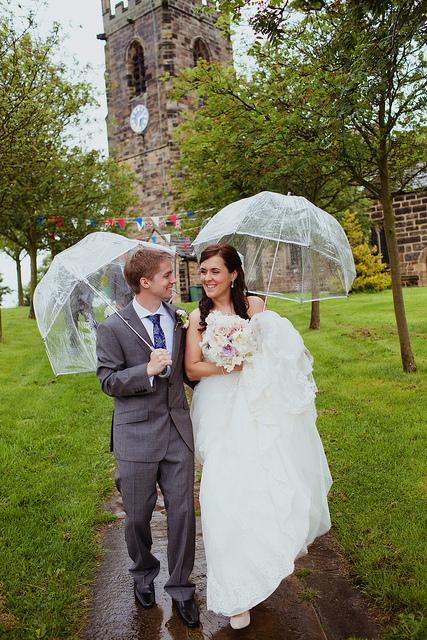Is it raining in the park?
Concise answer only. Yes. What are the people holding above their head?
Write a very short answer. Umbrellas. How many umbrellas is the man holding?
Short answer required. 1. Is it raining in this picture?
Concise answer only. Yes. Has the wedding occurred?
Keep it brief. Yes. Are the umbrellas plastic?
Answer briefly. Yes. 